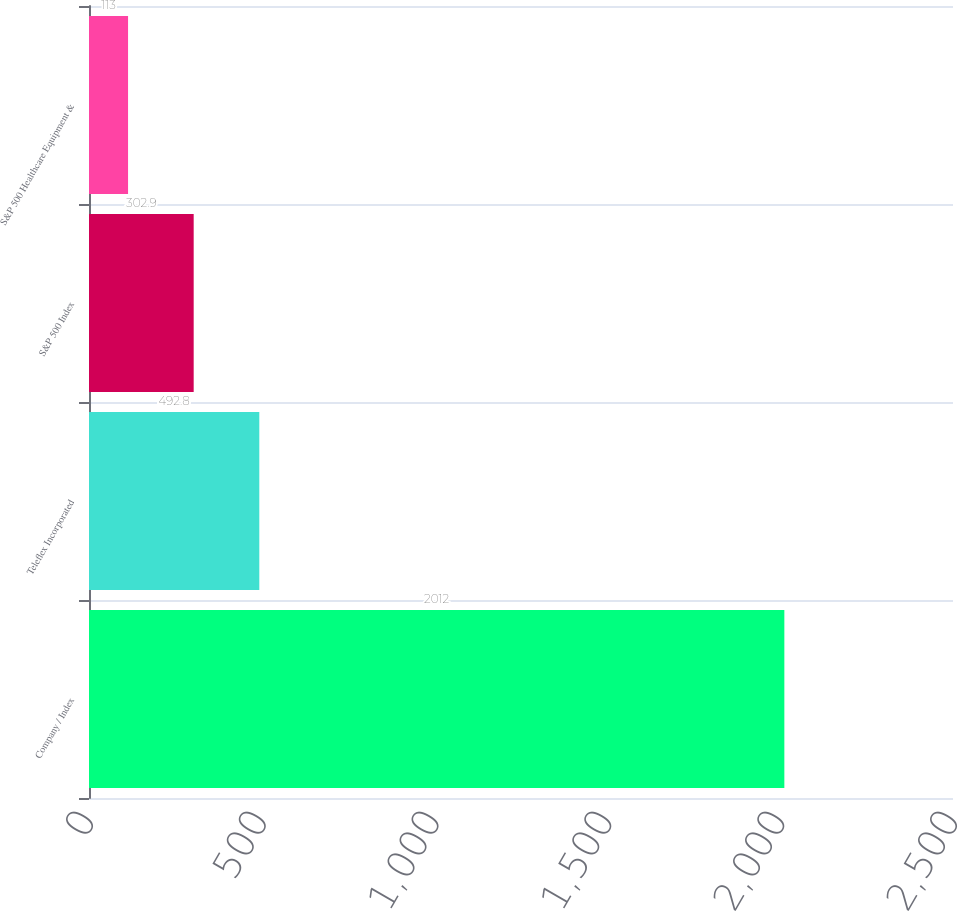<chart> <loc_0><loc_0><loc_500><loc_500><bar_chart><fcel>Company / Index<fcel>Teleflex Incorporated<fcel>S&P 500 Index<fcel>S&P 500 Healthcare Equipment &<nl><fcel>2012<fcel>492.8<fcel>302.9<fcel>113<nl></chart> 